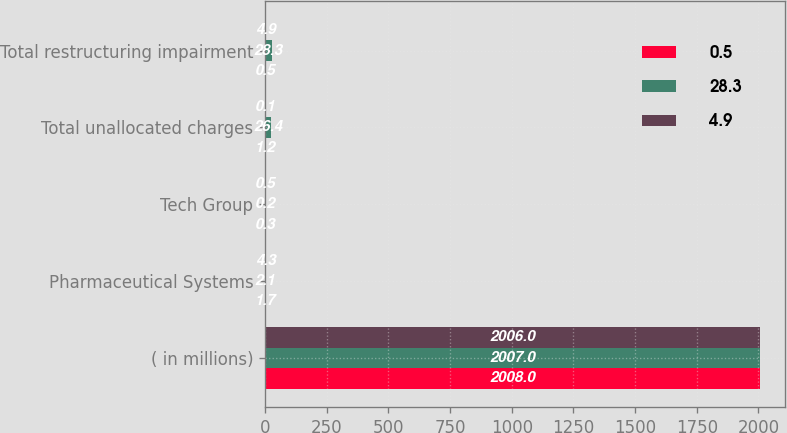Convert chart to OTSL. <chart><loc_0><loc_0><loc_500><loc_500><stacked_bar_chart><ecel><fcel>( in millions)<fcel>Pharmaceutical Systems<fcel>Tech Group<fcel>Total unallocated charges<fcel>Total restructuring impairment<nl><fcel>0.5<fcel>2008<fcel>1.7<fcel>0.3<fcel>1.2<fcel>0.5<nl><fcel>28.3<fcel>2007<fcel>2.1<fcel>0.2<fcel>26.4<fcel>28.3<nl><fcel>4.9<fcel>2006<fcel>4.3<fcel>0.5<fcel>0.1<fcel>4.9<nl></chart> 